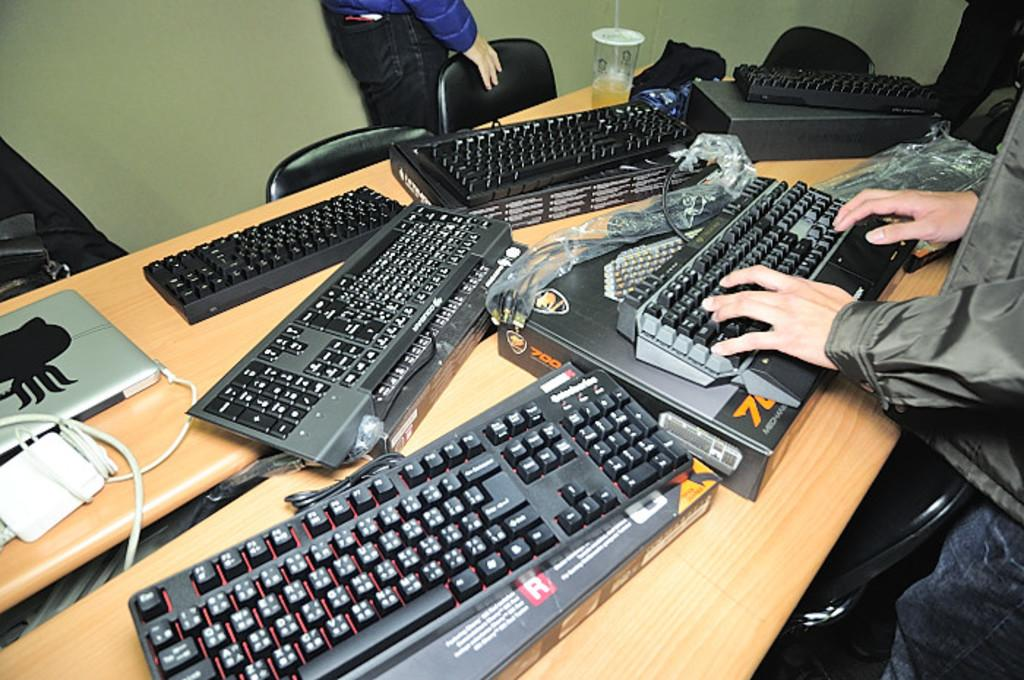<image>
Create a compact narrative representing the image presented. several black key boards on a table displayed on boxes with letter R and number 7 